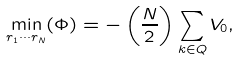<formula> <loc_0><loc_0><loc_500><loc_500>\min _ { { r } _ { 1 } \cdots { r } _ { N } } ( \Phi ) = - \left ( \frac { N } { 2 } \right ) \sum _ { { k } \in { Q } } V _ { 0 } ,</formula> 